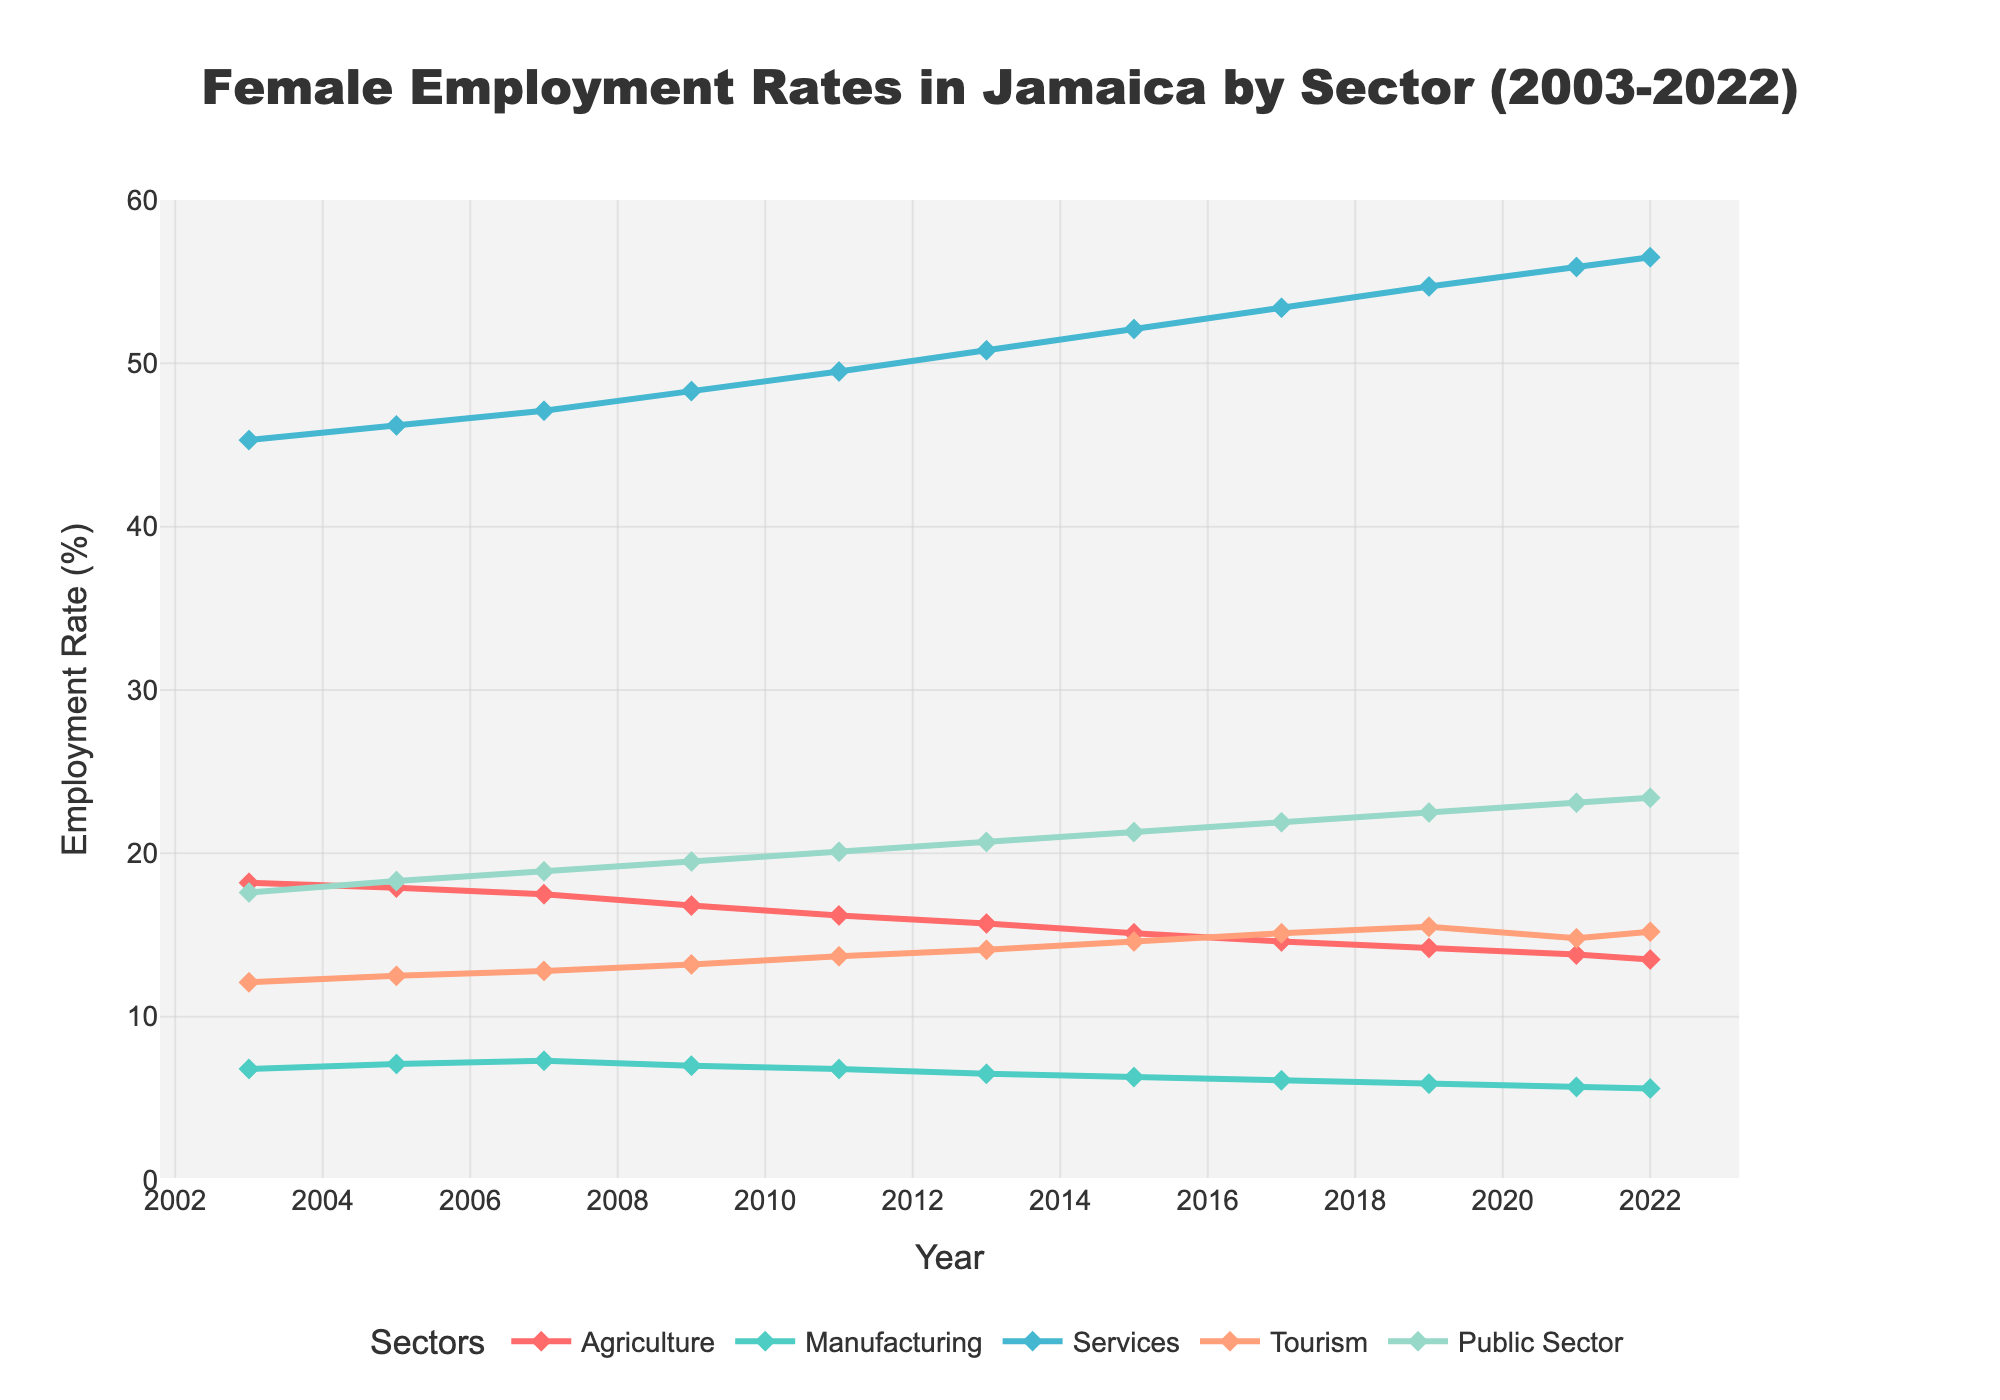What is the employment rate trend in the Services sector over the last 20 years? The employment rate in the Services sector consistently increased from 45.3% in 2003 to 56.5% in 2022 as observed from the rising line on the plot.
Answer: Increasing How did the employment rate in Agriculture compare between 2003 and 2022? The employment rate in Agriculture decreased from 18.2% in 2003 to 13.5% in 2022, indicated by the downward slope of the Agriculture line.
Answer: Decreased Which sector had the highest employment rate in 2022? In 2022, the Services sector had the highest employment rate at 56.5%, as shown by the peak of the Services line.
Answer: Services What arithmetic operations show the change in Public Sector employment rate between 2013 and 2021? To find the change, subtract the employment rate in 2013 (20.7%) from that in 2021 (23.1%): 23.1% - 20.7% = 2.4%.
Answer: 2.4% What is the difference in employment rates between the Manufacturing and Tourism sectors in 2020? Although there is no data directly for 2020, we can look at the adjacent years: In 2021, Manufacturing is 5.7% and Tourism is 14.8%. The difference: 14.8% - 5.7% = 9.1%.
Answer: 9.1% In which year did the Services sector employment rate first surpass 50%? The Services sector first surpassed 50% in 2013, as seen by the line crossing the 50% mark.
Answer: 2013 Which sector showed the least variation in employment rates over the 20-year period? The Manufacturing sector showed the least variation as its line remained relatively stable, fluctuating minimally around the 6-7% range.
Answer: Manufacturing How much did the Tourism sector employment rate increase from 2003 to 2022? The Tourism sector employment rate increased from 12.1% in 2003 to 15.2% in 2022. The increase is 15.2% - 12.1% = 3.1%.
Answer: 3.1% Which two sectors had a converging trend in employment rates towards the end of the period? The Tourism and Public Sector lines show converging trends with both increasing and their values getting closer.
Answer: Tourism and Public Sector How does the employment trend in Agriculture compare to that in Manufacturing from 2003 to 2022? Both sectors show decreasing trends, but Agriculture's rate fell more sharply from 18.2% to 13.5%, while Manufacturing's rate decreased more gradually from 6.8% to 5.6%.
Answer: Both decreasing, Agriculture more sharply 